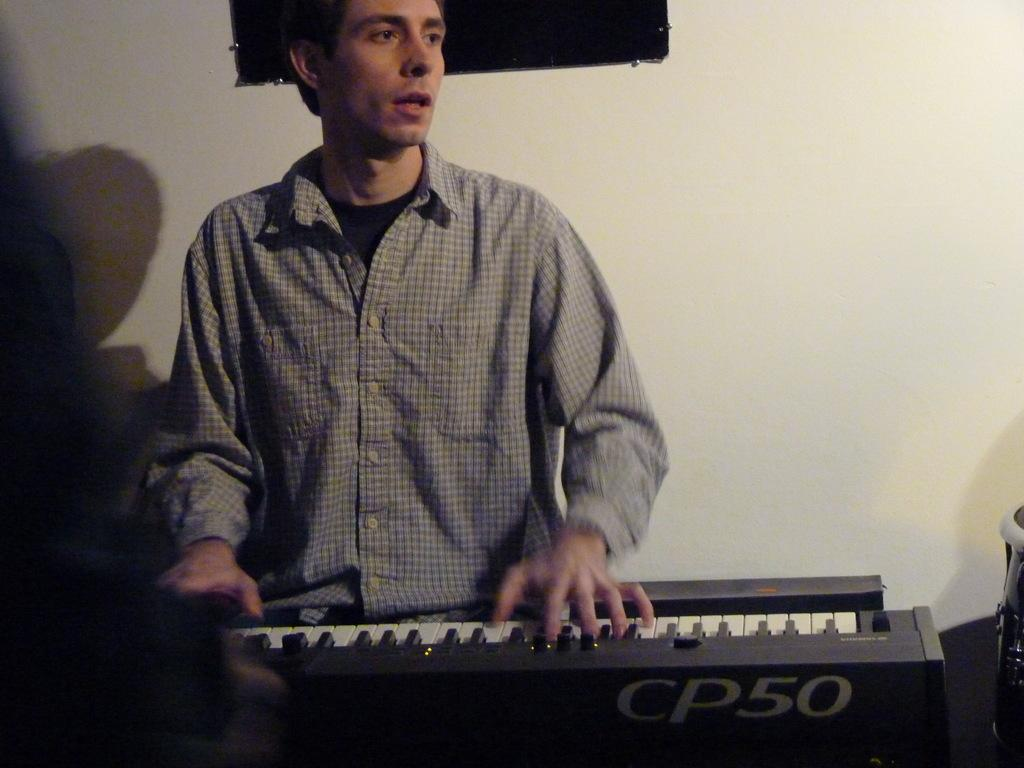Who is present in the image? There is a man in the image. What is the man doing in the image? The man is sitting and playing the piano. What can be seen behind the man in the image? There is a wall in the image. What type of trousers is the man wearing in the image? The provided facts do not mention the man's trousers, so we cannot determine the type of trousers he is wearing from the image. 